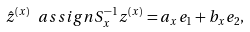Convert formula to latex. <formula><loc_0><loc_0><loc_500><loc_500>\hat { z } ^ { ( x ) } \ a s s i g n S _ { x } ^ { - 1 } z ^ { ( x ) } = a _ { x } e _ { 1 } + b _ { x } e _ { 2 } ,</formula> 